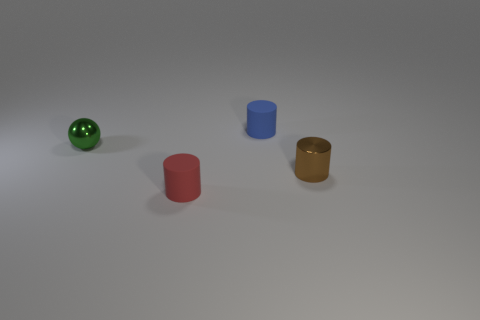Subtract all brown shiny cylinders. How many cylinders are left? 2 Add 1 brown cylinders. How many objects exist? 5 Subtract all spheres. How many objects are left? 3 Add 3 small green things. How many small green things exist? 4 Subtract 0 yellow cylinders. How many objects are left? 4 Subtract all blue blocks. Subtract all brown things. How many objects are left? 3 Add 2 tiny brown metal objects. How many tiny brown metal objects are left? 3 